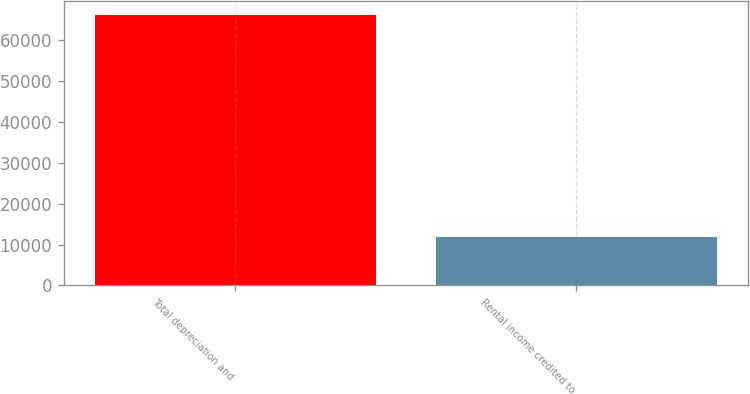Convert chart. <chart><loc_0><loc_0><loc_500><loc_500><bar_chart><fcel>Total depreciation and<fcel>Rental income credited to<nl><fcel>66089<fcel>11755<nl></chart> 